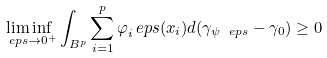<formula> <loc_0><loc_0><loc_500><loc_500>\liminf _ { \ e p s \to 0 ^ { + } } \int _ { B ^ { p } } \sum _ { i = 1 } ^ { p } \varphi _ { i } ^ { \ } e p s ( x _ { i } ) d ( \gamma _ { \psi _ { \ } e p s } - \gamma _ { 0 } ) \geq 0</formula> 